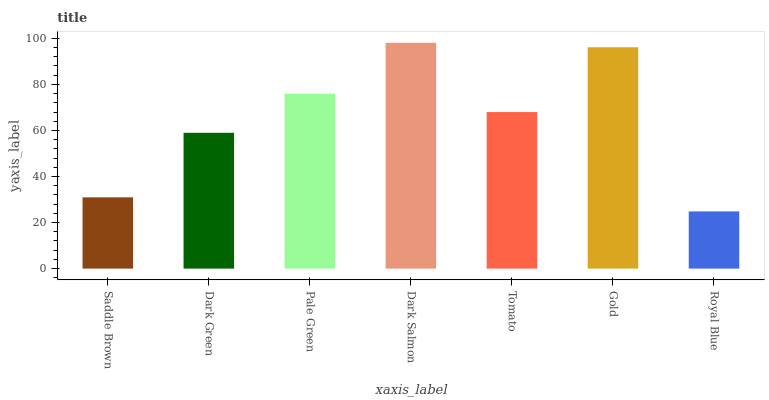Is Royal Blue the minimum?
Answer yes or no. Yes. Is Dark Salmon the maximum?
Answer yes or no. Yes. Is Dark Green the minimum?
Answer yes or no. No. Is Dark Green the maximum?
Answer yes or no. No. Is Dark Green greater than Saddle Brown?
Answer yes or no. Yes. Is Saddle Brown less than Dark Green?
Answer yes or no. Yes. Is Saddle Brown greater than Dark Green?
Answer yes or no. No. Is Dark Green less than Saddle Brown?
Answer yes or no. No. Is Tomato the high median?
Answer yes or no. Yes. Is Tomato the low median?
Answer yes or no. Yes. Is Saddle Brown the high median?
Answer yes or no. No. Is Dark Salmon the low median?
Answer yes or no. No. 